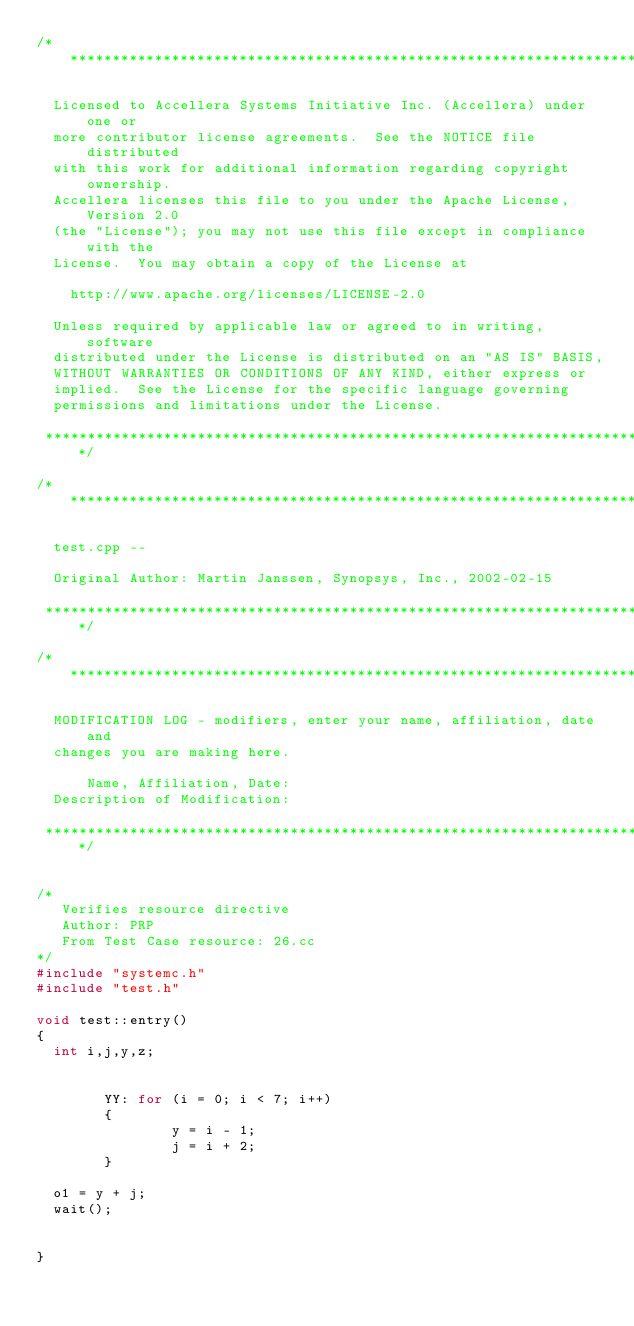<code> <loc_0><loc_0><loc_500><loc_500><_C++_>/*****************************************************************************

  Licensed to Accellera Systems Initiative Inc. (Accellera) under one or
  more contributor license agreements.  See the NOTICE file distributed
  with this work for additional information regarding copyright ownership.
  Accellera licenses this file to you under the Apache License, Version 2.0
  (the "License"); you may not use this file except in compliance with the
  License.  You may obtain a copy of the License at

    http://www.apache.org/licenses/LICENSE-2.0

  Unless required by applicable law or agreed to in writing, software
  distributed under the License is distributed on an "AS IS" BASIS,
  WITHOUT WARRANTIES OR CONDITIONS OF ANY KIND, either express or
  implied.  See the License for the specific language governing
  permissions and limitations under the License.

 *****************************************************************************/

/*****************************************************************************

  test.cpp -- 

  Original Author: Martin Janssen, Synopsys, Inc., 2002-02-15

 *****************************************************************************/

/*****************************************************************************

  MODIFICATION LOG - modifiers, enter your name, affiliation, date and
  changes you are making here.

      Name, Affiliation, Date:
  Description of Modification:

 *****************************************************************************/


/* 
   Verifies resource directive
   Author: PRP 
   From Test Case resource: 26.cc
*/
#include "systemc.h"
#include "test.h"

void test::entry() 
{
  int i,j,y,z;
 
 
        YY: for (i = 0; i < 7; i++)
        {
                y = i - 1;
                j = i + 2;
        }
  
  o1 = y + j;
  wait();


}
</code> 